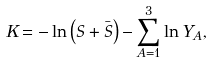Convert formula to latex. <formula><loc_0><loc_0><loc_500><loc_500>K = - \ln \left ( S + { \bar { S } } \right ) - \sum _ { A = 1 } ^ { 3 } \ln Y _ { A } ,</formula> 